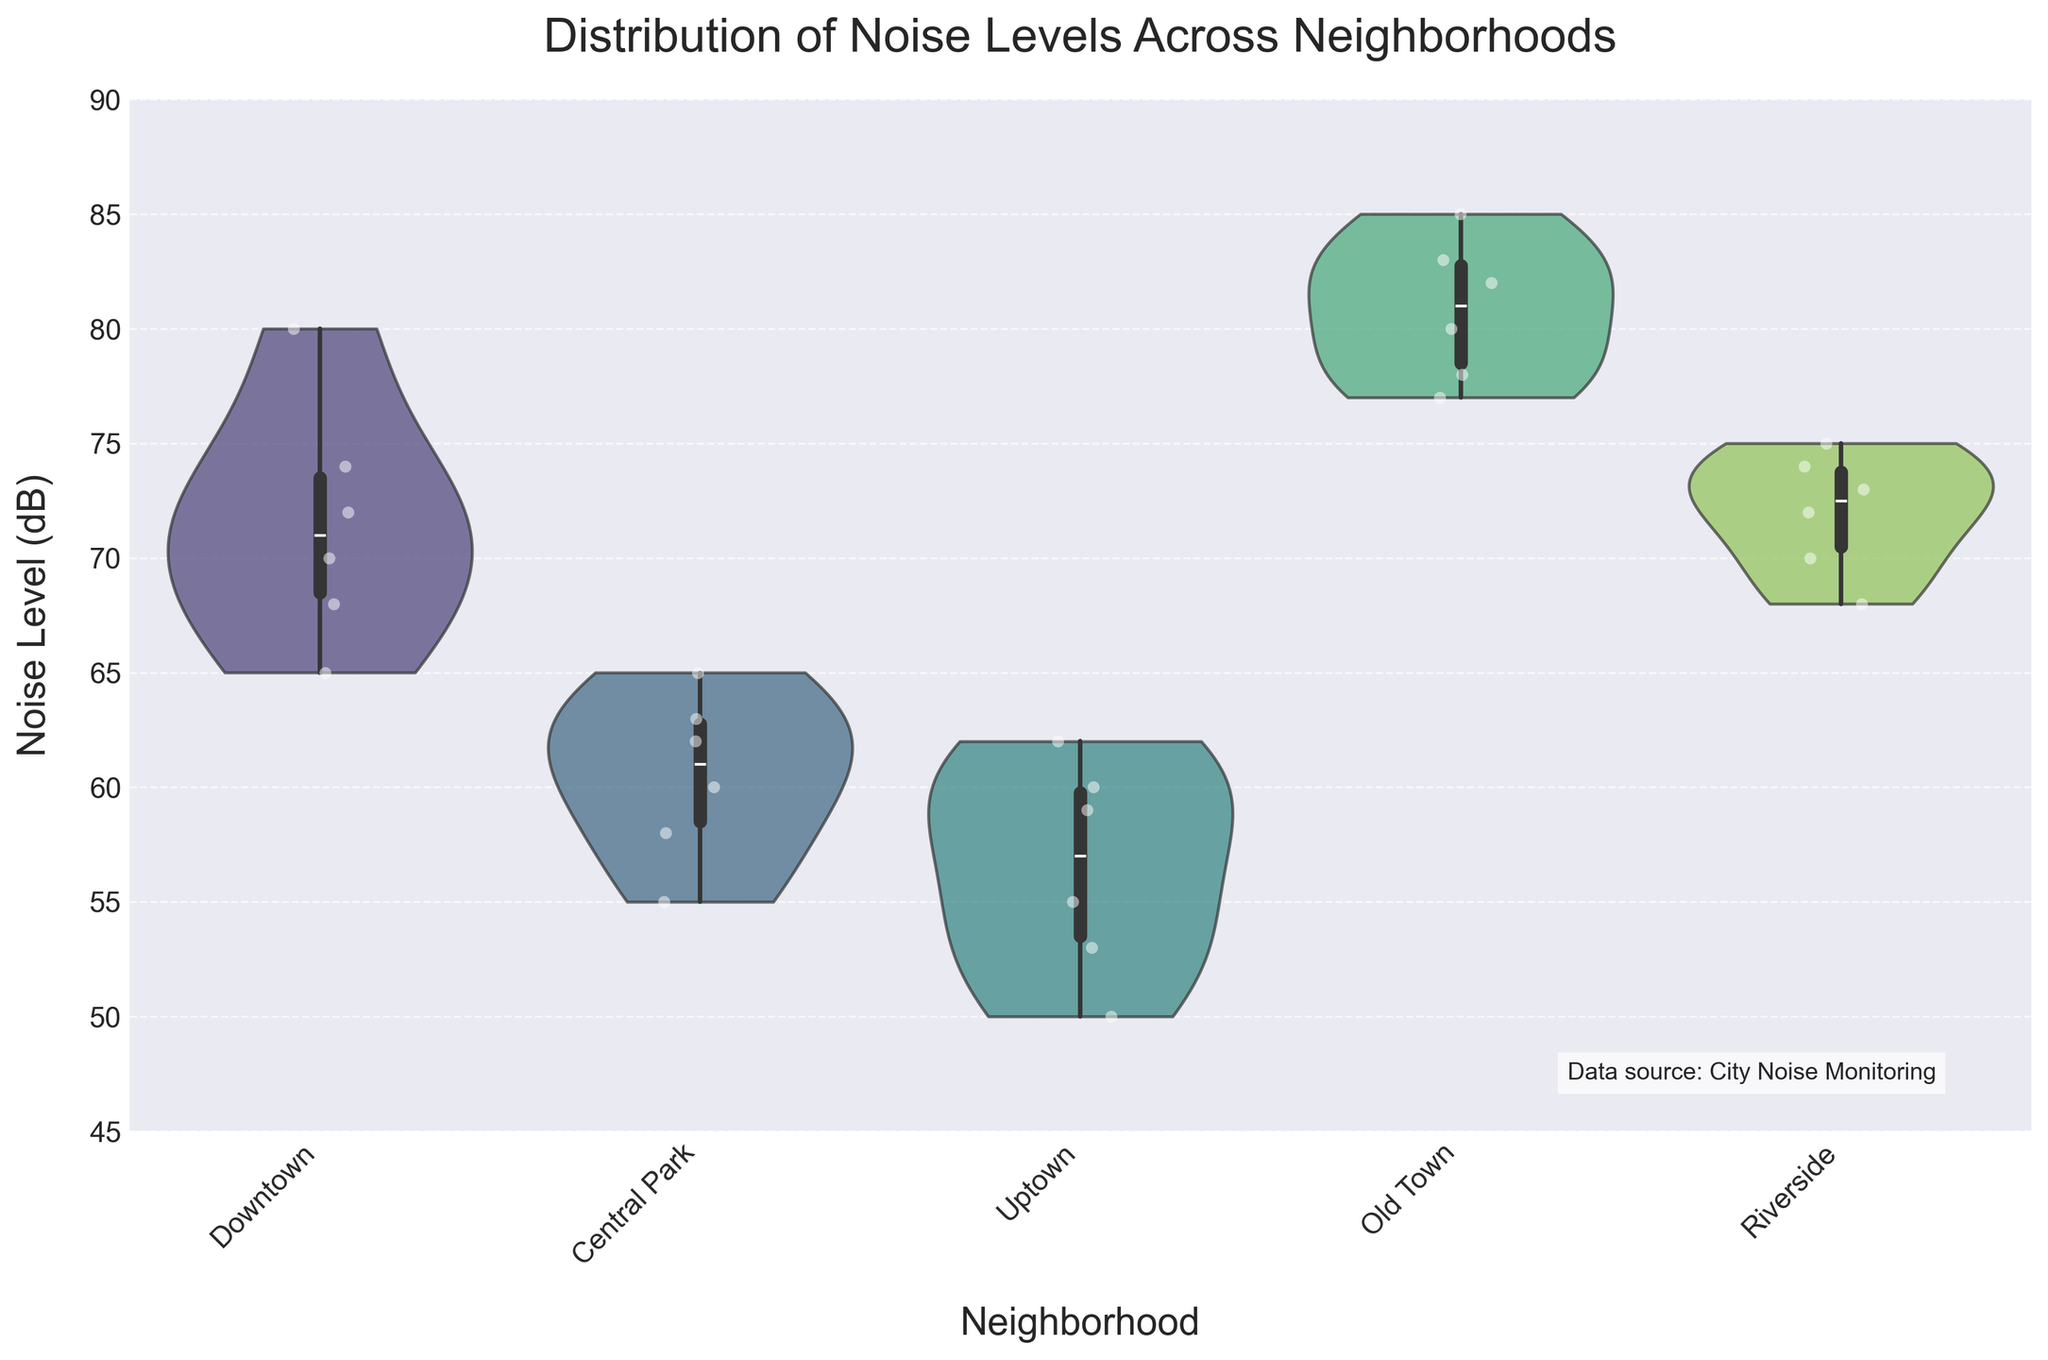What is the title of the figure? The title of the figure is displayed prominently at the top.
Answer: Distribution of Noise Levels Across Neighborhoods Which neighborhood appears to have the highest noise level on average? The widest part of the violin plot indicates the density of noise levels around that range. The plot for Old Town is centered around the highest decibel levels.
Answer: Old Town Which neighborhoods show a higher variation in noise levels? The width of the violin plot at different points reflects the distribution and spread of values. The Downtown and Old Town neighborhoods have broader distributions compared to others.
Answer: Downtown, Old Town What is the range of noise levels reported in Uptown? Check the bottom and top of the violin plot and jittered points for Uptown; it ranges from the minimum to the maximum recorded values.
Answer: 50–62 dB How do the noise levels in Riverside compare to those in Central Park? Compare the position and spread of the violin plots and jittered points for both neighborhoods. The noise levels in Riverside are generally higher and more tightly packed compared to Central Park.
Answer: Higher in Riverside Which neighborhood shows the least amount of noise? Identify the neighborhood with the violin plot centered on the lowest decibel values. Uptown is centered around the lower end of the noise level range.
Answer: Uptown Are there any outliers in the dataset, and if so, which neighborhood do they belong to? Outliers often appear as isolated jittered points far from the dense center of the violin plot. The point at 80 dB in Downtown appears isolated from the others.
Answer: Downtown What can be inferred about noise complaints in Old Town compared to Uptown? By observing the difference in the range and distribution of noise levels, it can be inferred that noise complaints are likely higher in Old Town compared to Uptown.
Answer: More in Old Town Is there any overlap in the noise level ranges between Downtown and Riverside? Examine the overlap in the spread of the violin plots for Downtown and Riverside. Both neighborhoods show similar upper limits around 74-80 dB.
Answer: Yes What does the presence of jittered points within the violin plots tell us? Jittered points are individual data points that show exact values, giving a clearer picture of how many data points fall within each part of the distribution. They help in identifying the density and clustering within each neighborhood.
Answer: Distribution clarity 